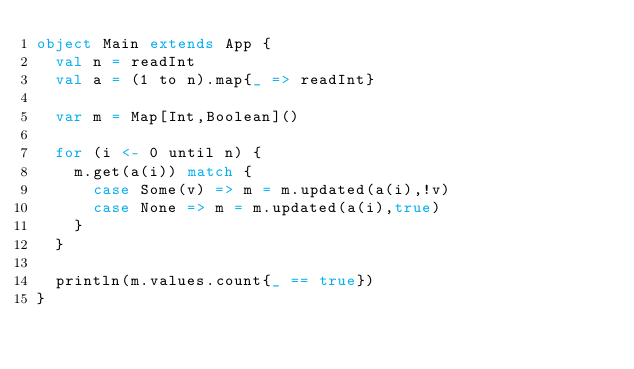<code> <loc_0><loc_0><loc_500><loc_500><_Scala_>object Main extends App {
  val n = readInt
  val a = (1 to n).map{_ => readInt}
  
  var m = Map[Int,Boolean]()
  
  for (i <- 0 until n) {
    m.get(a(i)) match {
      case Some(v) => m = m.updated(a(i),!v)
      case None => m = m.updated(a(i),true)
    }
  }
  
  println(m.values.count{_ == true})
}</code> 